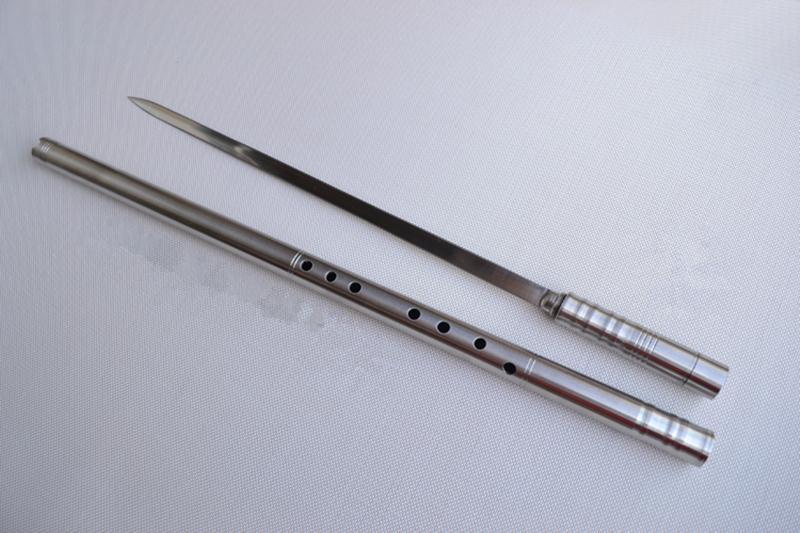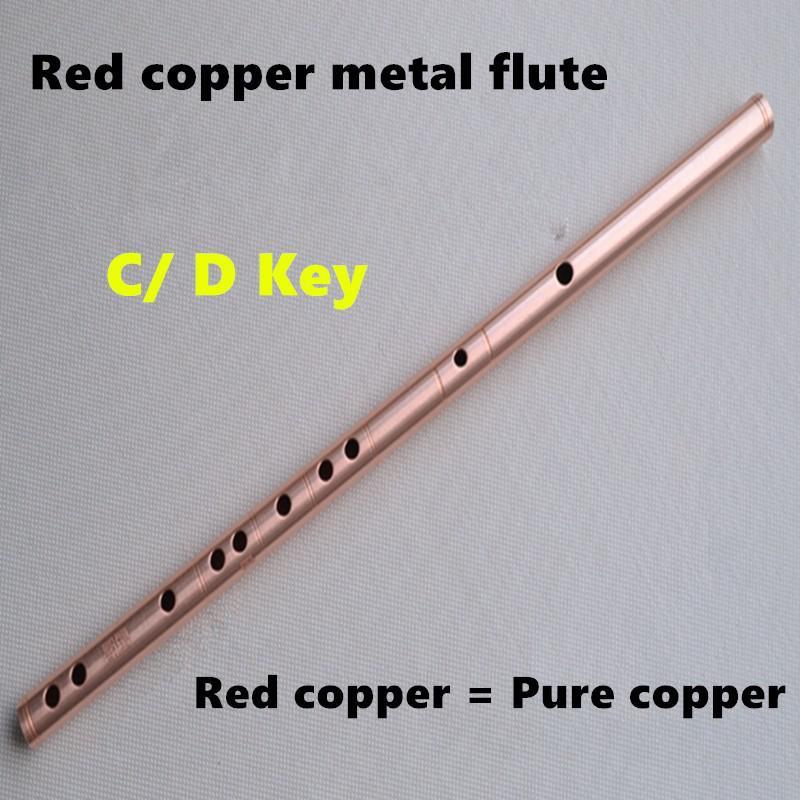The first image is the image on the left, the second image is the image on the right. For the images displayed, is the sentence "There are more instruments in the image on the right." factually correct? Answer yes or no. No. The first image is the image on the left, the second image is the image on the right. Examine the images to the left and right. Is the description "The left image shows only a flute displayed at an angle, and the right image shows a measuring tape, a sword and a flute displayed diagonally." accurate? Answer yes or no. No. 